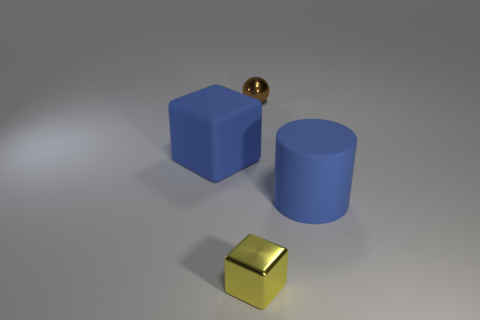Add 2 blue matte cylinders. How many objects exist? 6 Subtract 1 cylinders. How many cylinders are left? 0 Add 4 tiny yellow shiny blocks. How many tiny yellow shiny blocks exist? 5 Subtract all yellow cubes. How many cubes are left? 1 Subtract 0 gray spheres. How many objects are left? 4 Subtract all spheres. How many objects are left? 3 Subtract all blue balls. Subtract all cyan cubes. How many balls are left? 1 Subtract all green blocks. How many gray spheres are left? 0 Subtract all cyan rubber cubes. Subtract all tiny yellow things. How many objects are left? 3 Add 3 tiny shiny objects. How many tiny shiny objects are left? 5 